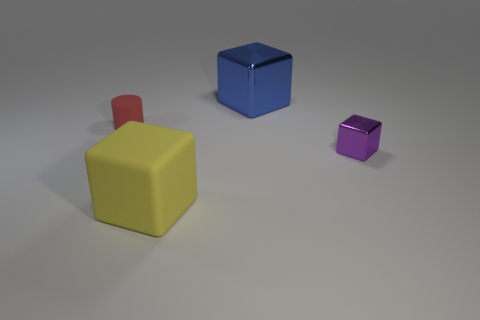Subtract all big matte blocks. How many blocks are left? 2 Add 2 blue matte objects. How many objects exist? 6 Subtract all cylinders. How many objects are left? 3 Subtract all red cubes. Subtract all purple spheres. How many cubes are left? 3 Subtract all tiny gray cylinders. Subtract all large blocks. How many objects are left? 2 Add 4 large metal cubes. How many large metal cubes are left? 5 Add 1 big green metal balls. How many big green metal balls exist? 1 Subtract 0 blue cylinders. How many objects are left? 4 